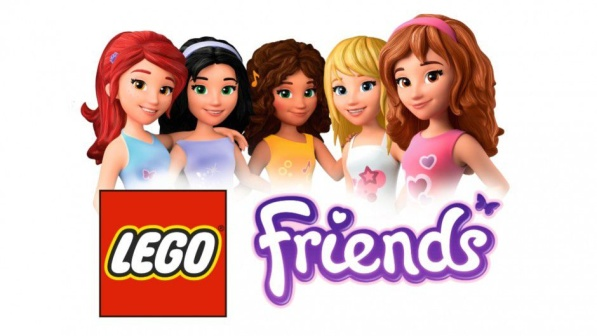What are some unique design elements of these characters that make them stand out from traditional Lego figures? Unlike the classic, blocky Lego minifigures, the characters in the Lego Friends image exhibit a more detailed and naturalistic design. These figures, known as 'mini-dolls,' have distinctively sculpted hairdos, curved silhouettes, and more articulated arms and legs which allow for dynamic posing. Their outfits and accessories are varied, echoing the latest trends and encouraging a personalized play experience. Facial features are given special attention too, with each character displaying unique expressions that enhance their individuality. These carefully crafted design elements provide a fresh take on traditional Lego figures and target players who might seek a more relatable and humanlike representation in their toys. 